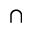Convert formula to latex. <formula><loc_0><loc_0><loc_500><loc_500>\cap</formula> 